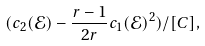<formula> <loc_0><loc_0><loc_500><loc_500>( c _ { 2 } ( \mathcal { E } ) - \frac { r - 1 } { 2 r } c _ { 1 } ( \mathcal { E } ) ^ { 2 } ) / [ C ] ,</formula> 